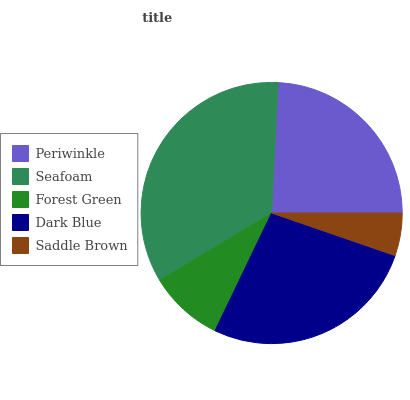Is Saddle Brown the minimum?
Answer yes or no. Yes. Is Seafoam the maximum?
Answer yes or no. Yes. Is Forest Green the minimum?
Answer yes or no. No. Is Forest Green the maximum?
Answer yes or no. No. Is Seafoam greater than Forest Green?
Answer yes or no. Yes. Is Forest Green less than Seafoam?
Answer yes or no. Yes. Is Forest Green greater than Seafoam?
Answer yes or no. No. Is Seafoam less than Forest Green?
Answer yes or no. No. Is Periwinkle the high median?
Answer yes or no. Yes. Is Periwinkle the low median?
Answer yes or no. Yes. Is Dark Blue the high median?
Answer yes or no. No. Is Saddle Brown the low median?
Answer yes or no. No. 